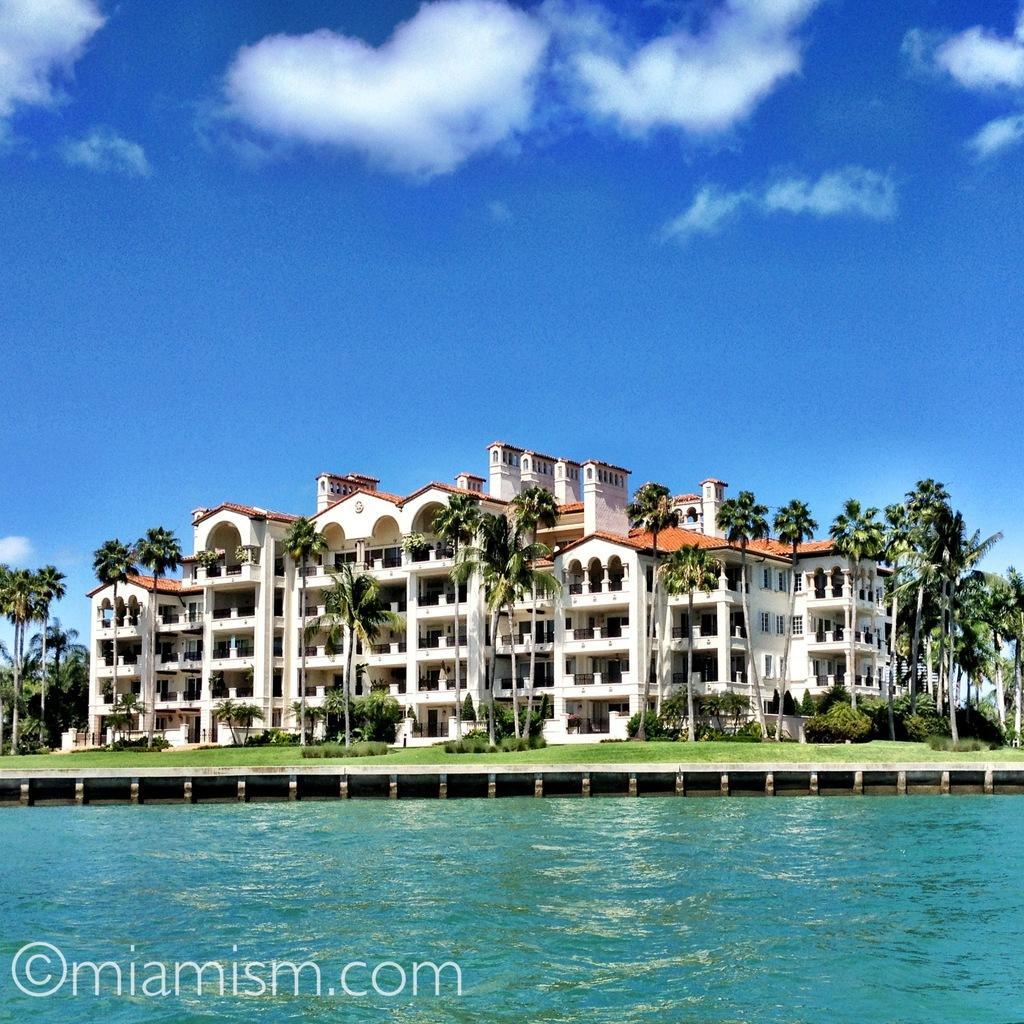In one or two sentences, can you explain what this image depicts? At the bottom of the image there is water. Behind the water on the land there is grass and also there are trees and plants. Behind them there is building with walls, windows, arches, walls, pillars, roofs and chimneys. At the top of the image there is sky with clouds. 